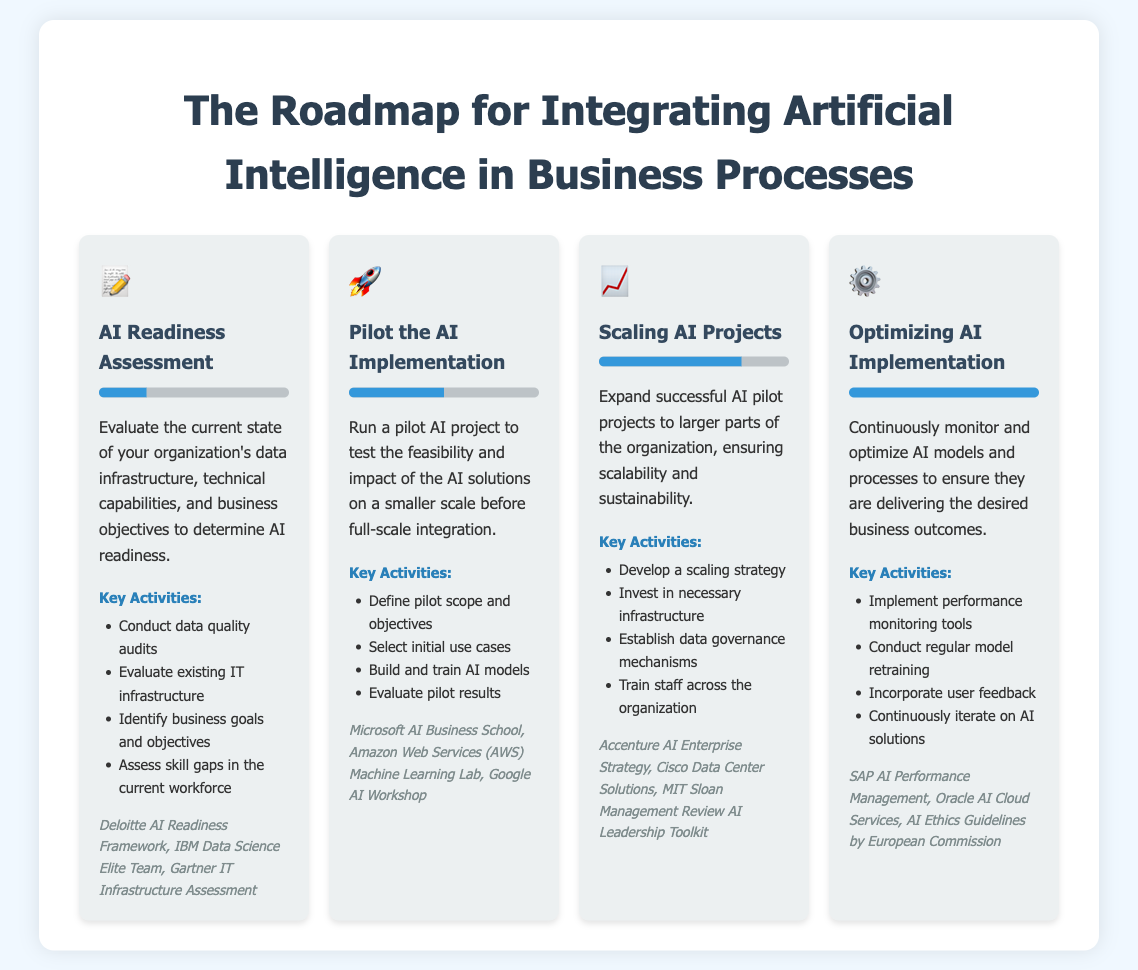What is the first step in the AI integration roadmap? The first step is the AI Readiness Assessment, which evaluates the current state of data infrastructure and business objectives.
Answer: AI Readiness Assessment What symbol is used to represent the pilot phase? The pilot phase is represented by a rocket icon, symbolizing launch and experimentation.
Answer: 🚀 What percentage completion is indicated for the scaling phase? The scaling phase shows 75% completion, indicating significant progress in expanding AI projects.
Answer: 75% Which organization is associated with performance monitoring tools in the optimization phase? The organization mentioned for performance monitoring tools in the optimization phase is SAP.
Answer: SAP What is the main focus during the optimization step? The focus during the optimization step is to continuously monitor and optimize AI models and processes.
Answer: Continuous monitoring and optimization List one key activity in the AI Readiness Assessment. One key activity is conducting data quality audits, which is essential for evaluating data infrastructure.
Answer: Conduct data quality audits What is the overall goal of scaling AI projects? The overall goal is to ensure scalability and sustainability of successful AI pilot projects.
Answer: Scalability and sustainability Which key activity is emphasized under the pilot phase? Building and training AI models is emphasized as a crucial activity during the pilot phase.
Answer: Build and train AI models What is a unique feature of the document type? A unique feature is the visual representation of progress bars, indicating completion for each phase.
Answer: Visual representation of progress bars 